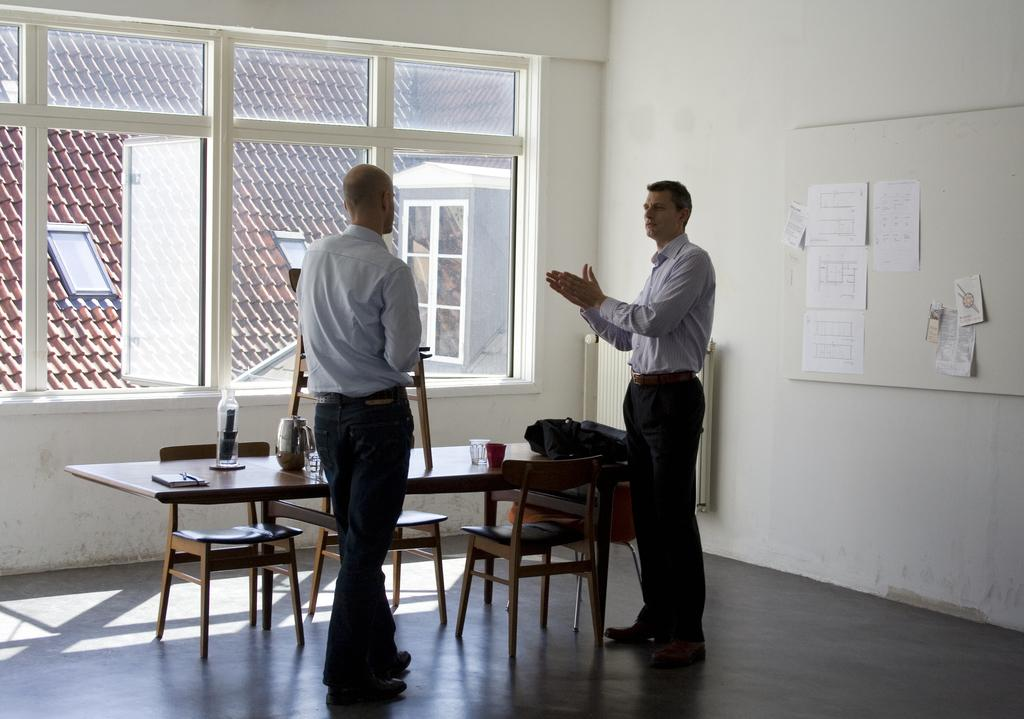How many people are present in the image? There are two men standing in the image. What type of furniture can be seen in the image? There are chairs and a table in the image. What is on the wall in the image? There are papers on the wall in the image. What objects are on the table in the image? There are glasses on the table in the image. What type of rings can be seen on the fingers of the men in the image? There is no indication of rings on the fingers of the men in the image. What color is the paint on the walls in the image? There is no mention of paint or wall color in the image; only papers are mentioned on the wall. 